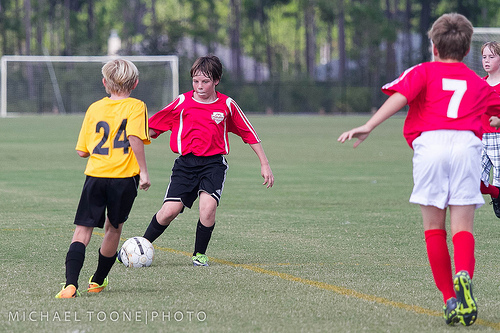<image>
Can you confirm if the boy is behind the ball? Yes. From this viewpoint, the boy is positioned behind the ball, with the ball partially or fully occluding the boy. Where is the kid in relation to the ball? Is it in front of the ball? No. The kid is not in front of the ball. The spatial positioning shows a different relationship between these objects. 